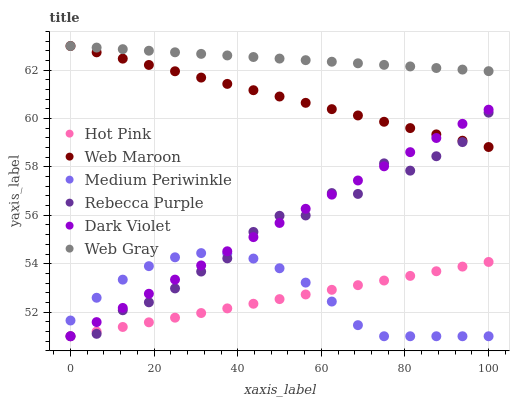Does Hot Pink have the minimum area under the curve?
Answer yes or no. Yes. Does Web Gray have the maximum area under the curve?
Answer yes or no. Yes. Does Web Maroon have the minimum area under the curve?
Answer yes or no. No. Does Web Maroon have the maximum area under the curve?
Answer yes or no. No. Is Dark Violet the smoothest?
Answer yes or no. Yes. Is Rebecca Purple the roughest?
Answer yes or no. Yes. Is Web Maroon the smoothest?
Answer yes or no. No. Is Web Maroon the roughest?
Answer yes or no. No. Does Hot Pink have the lowest value?
Answer yes or no. Yes. Does Web Maroon have the lowest value?
Answer yes or no. No. Does Web Maroon have the highest value?
Answer yes or no. Yes. Does Hot Pink have the highest value?
Answer yes or no. No. Is Rebecca Purple less than Web Gray?
Answer yes or no. Yes. Is Web Gray greater than Medium Periwinkle?
Answer yes or no. Yes. Does Web Maroon intersect Web Gray?
Answer yes or no. Yes. Is Web Maroon less than Web Gray?
Answer yes or no. No. Is Web Maroon greater than Web Gray?
Answer yes or no. No. Does Rebecca Purple intersect Web Gray?
Answer yes or no. No. 